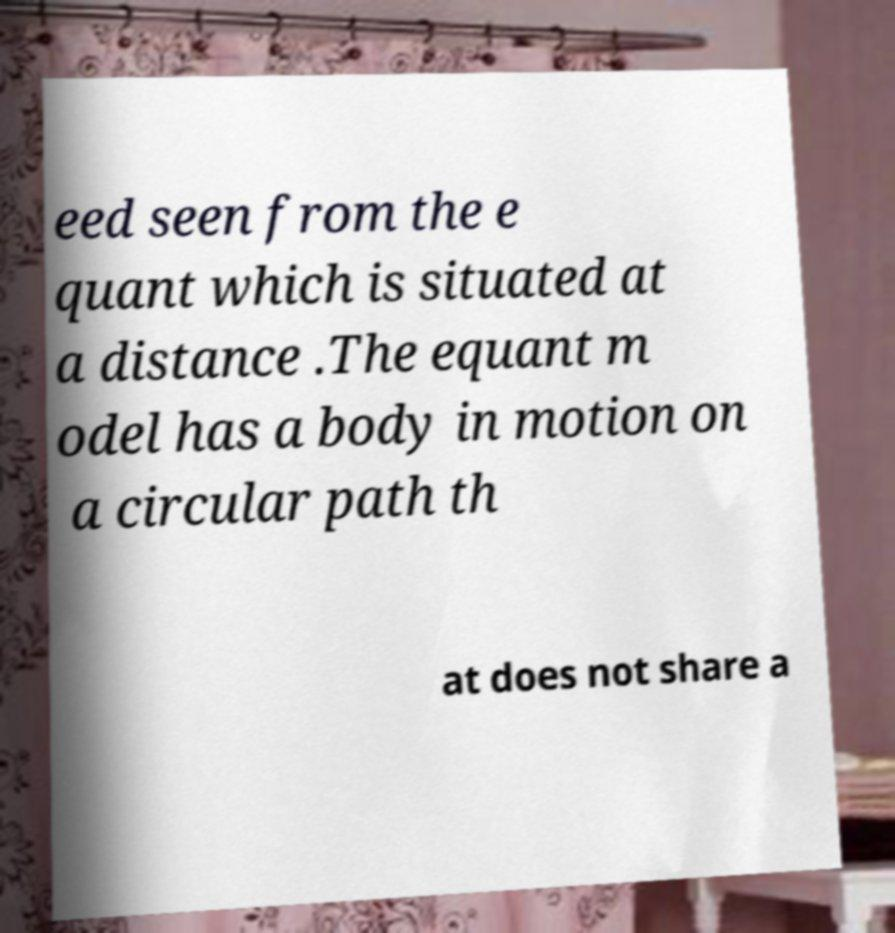Can you read and provide the text displayed in the image?This photo seems to have some interesting text. Can you extract and type it out for me? eed seen from the e quant which is situated at a distance .The equant m odel has a body in motion on a circular path th at does not share a 